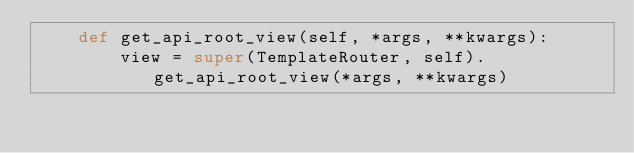<code> <loc_0><loc_0><loc_500><loc_500><_Python_>    def get_api_root_view(self, *args, **kwargs):
        view = super(TemplateRouter, self).get_api_root_view(*args, **kwargs)
</code> 